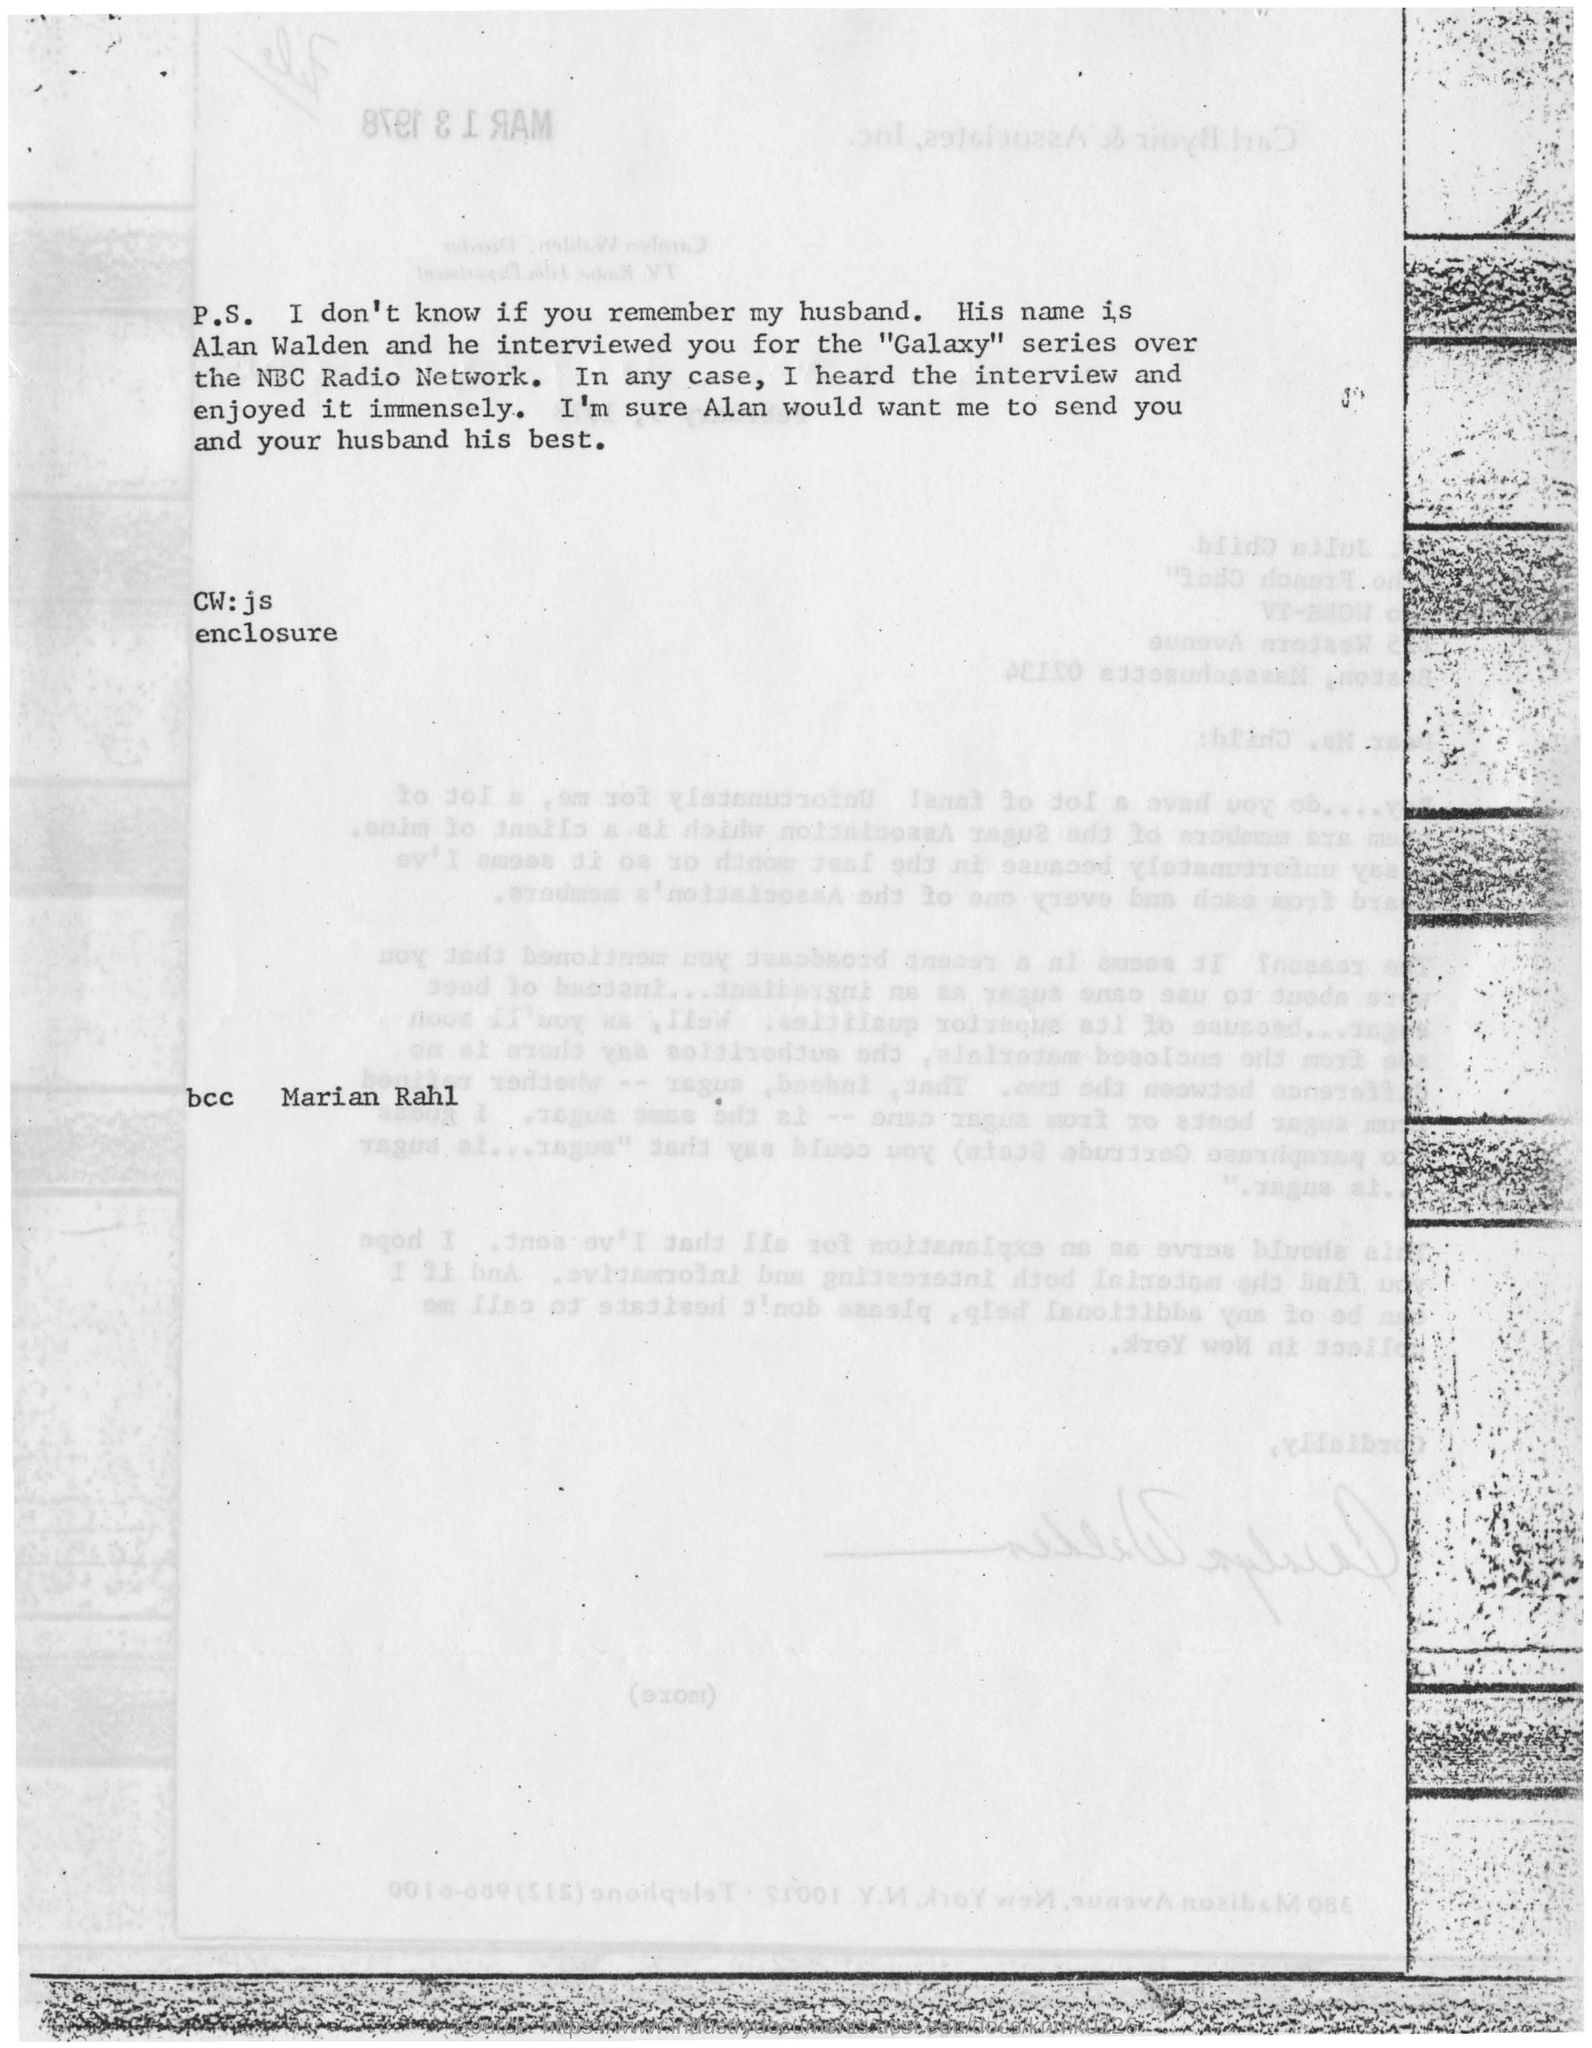Which person is mentioned in bcc?
Offer a terse response. Marian Rahl. 